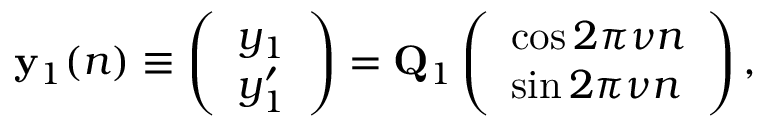Convert formula to latex. <formula><loc_0><loc_0><loc_500><loc_500>\begin{array} { r } { { y } _ { 1 } ( n ) \equiv \left ( \begin{array} { l } { y _ { 1 } } \\ { y _ { 1 } ^ { \prime } } \end{array} \right ) = { Q } _ { 1 } \left ( \begin{array} { l } { \cos 2 \pi \nu n } \\ { \sin 2 \pi \nu n } \end{array} \right ) , } \end{array}</formula> 